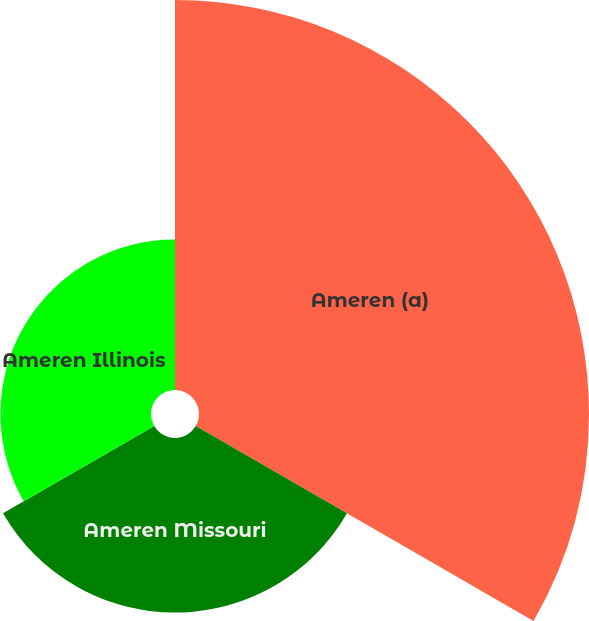<chart> <loc_0><loc_0><loc_500><loc_500><pie_chart><fcel>Ameren (a)<fcel>Ameren Missouri<fcel>Ameren Illinois<nl><fcel>54.53%<fcel>24.41%<fcel>21.06%<nl></chart> 